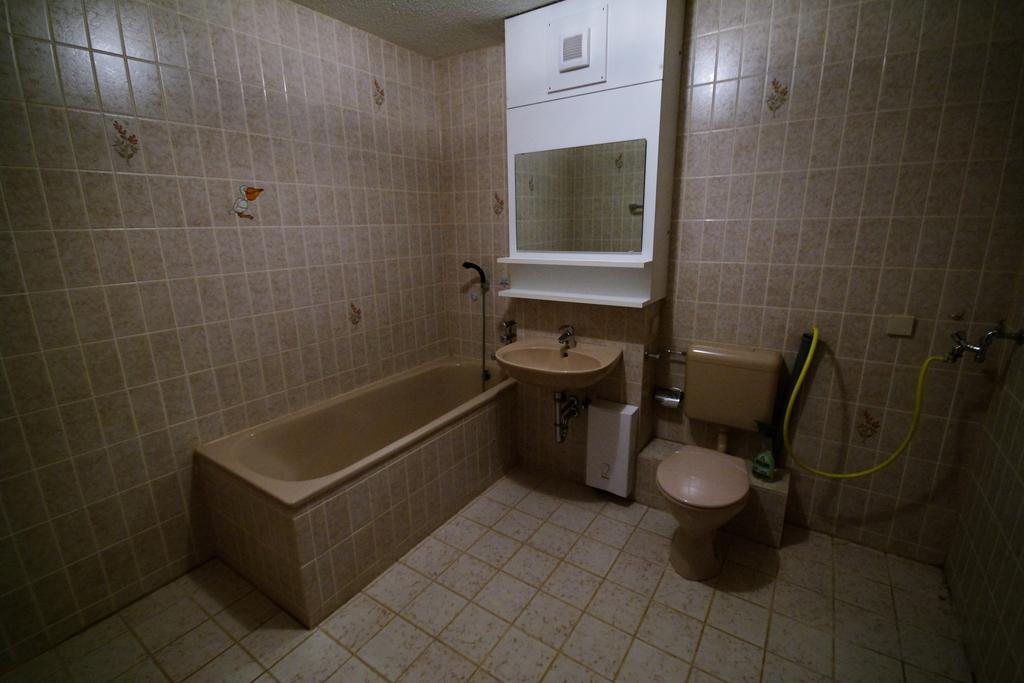Please provide a concise description of this image. This image is taken in the bathroom and here we can see a bathtub, sink, toilet and there is a tap with pipe. In the background, we can see a stand and there is a wall. At the bottom, there is floor. 